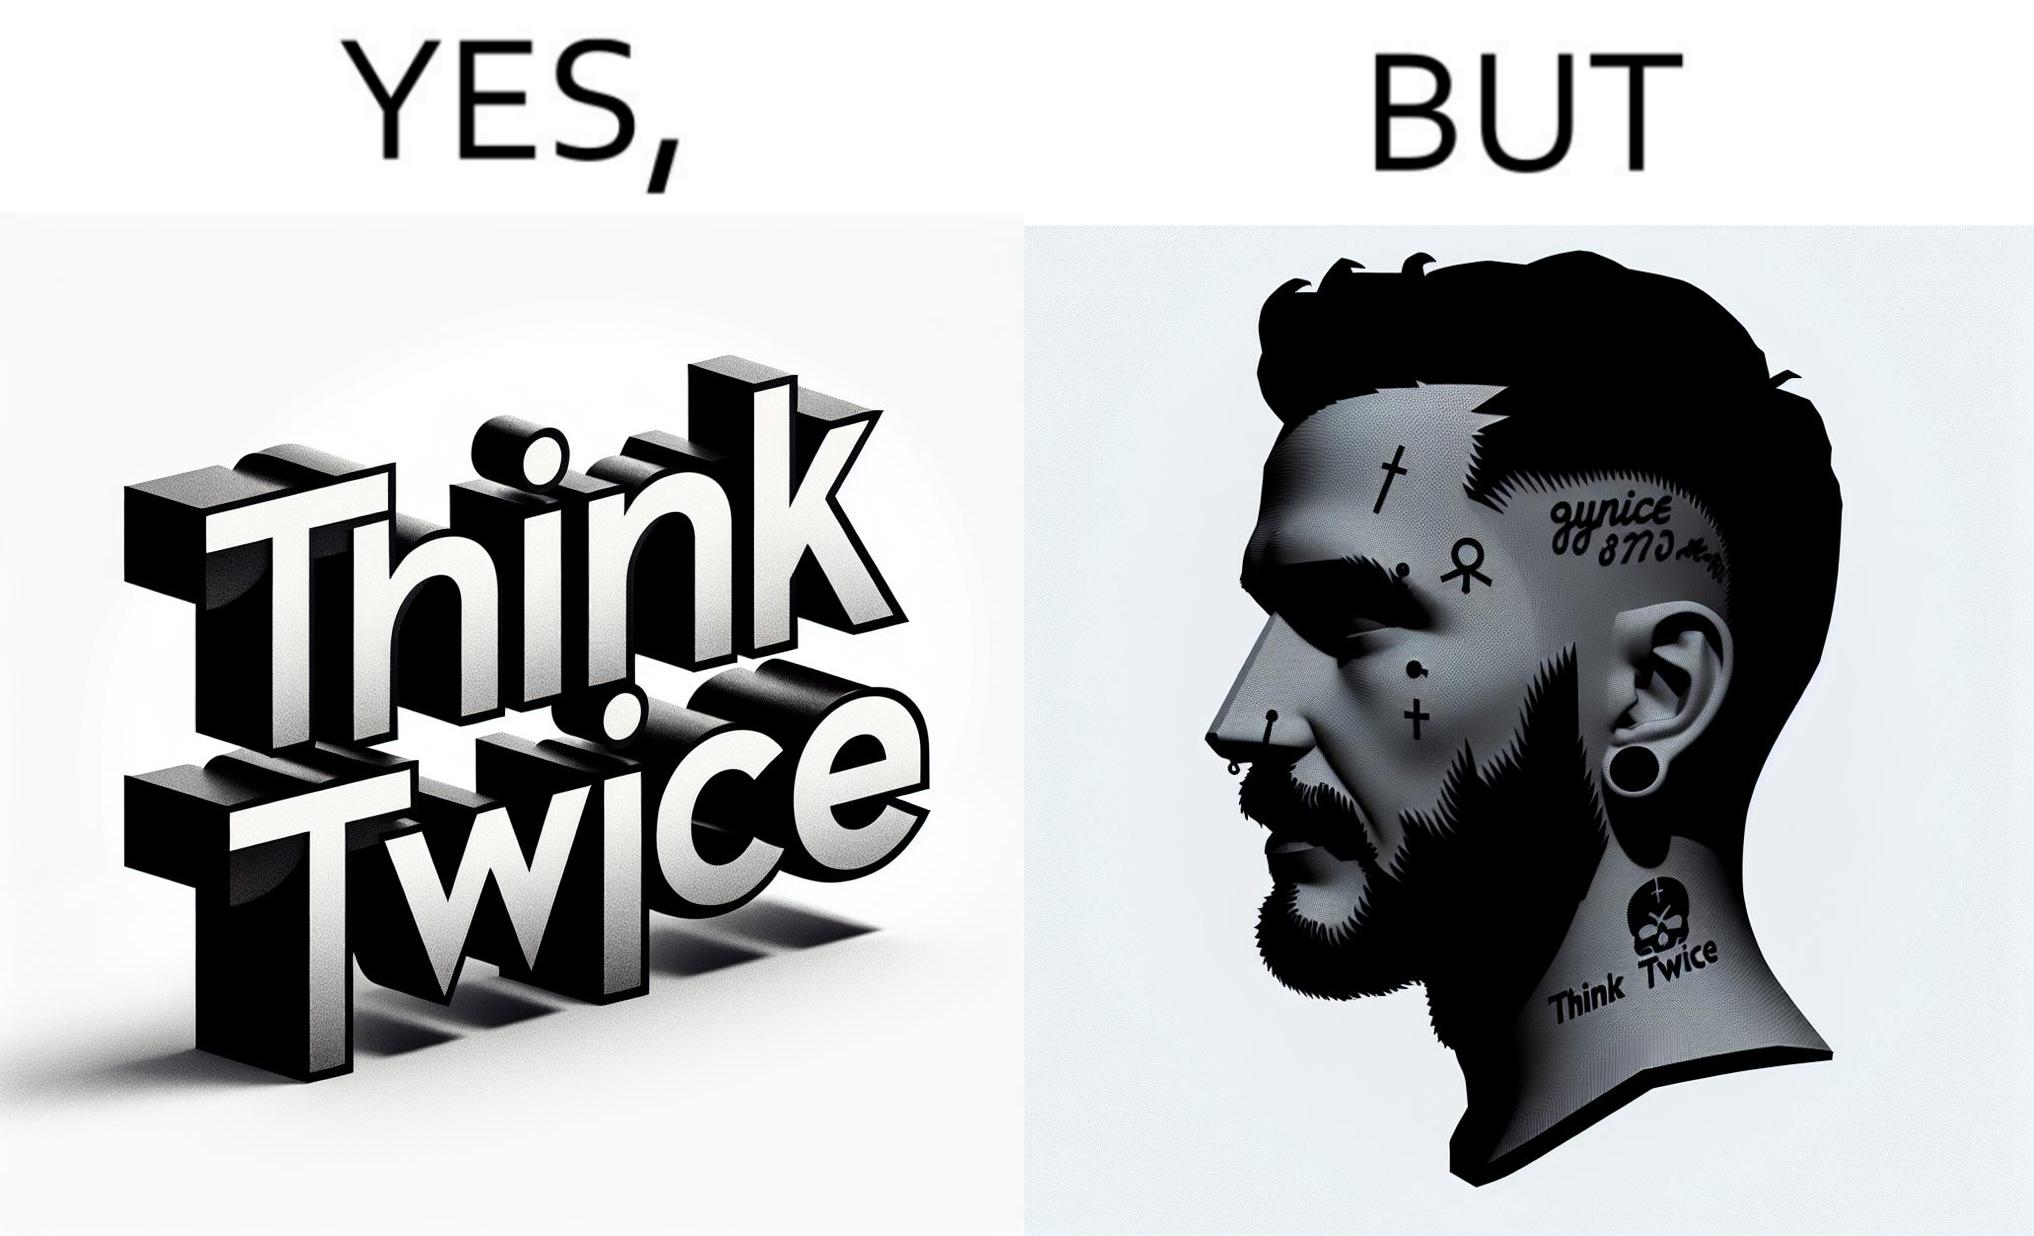Describe the contrast between the left and right parts of this image. In the left part of the image: The image shows a text in english saying "Think Twice". The font seems very fashionable. In the right part of the image: The image shows the face of a man with a tattoo on the left side of a forehead saying "Think Twice". The man is wearing a nose ring and has a cut on his left eyebrow. He also has a small tattoo of the cross a little below his left eye. 